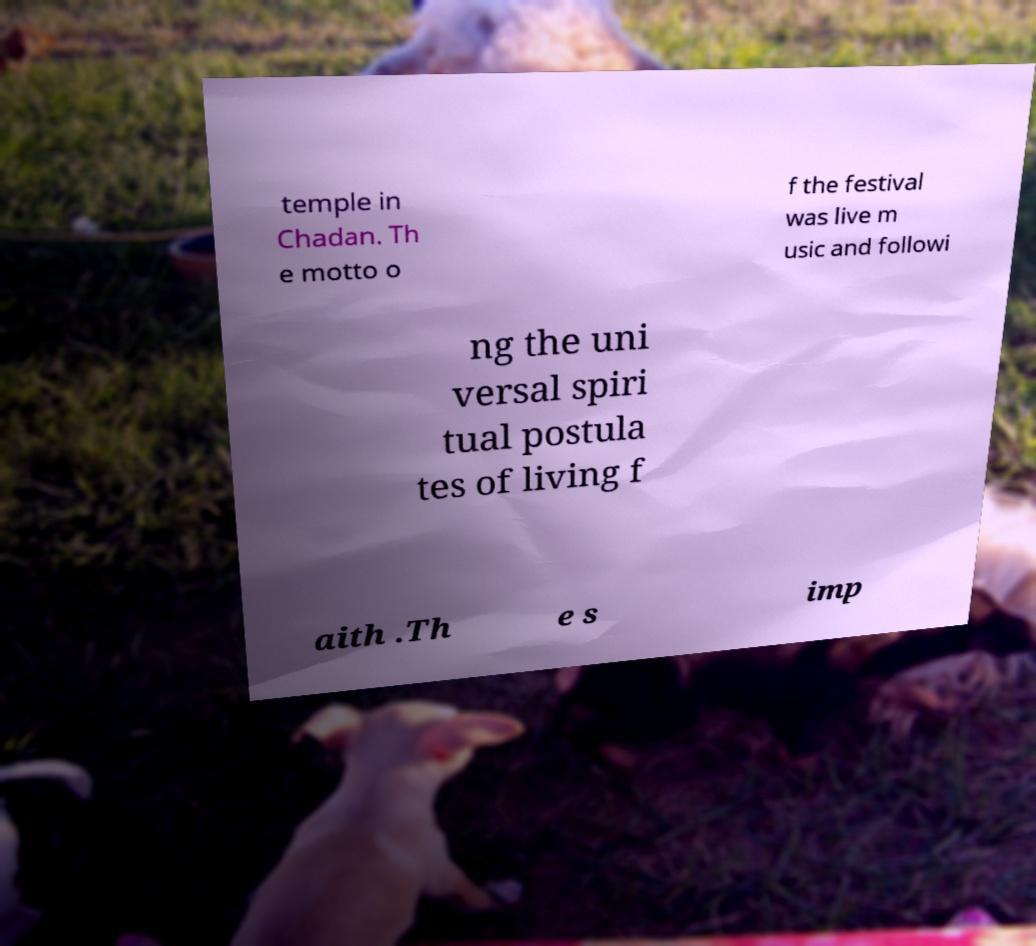Could you extract and type out the text from this image? temple in Chadan. Th e motto o f the festival was live m usic and followi ng the uni versal spiri tual postula tes of living f aith .Th e s imp 